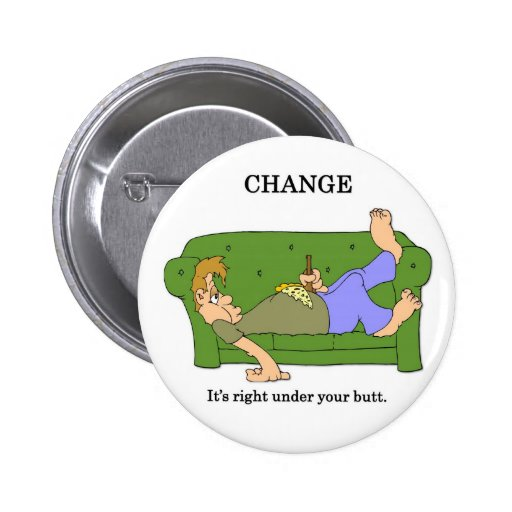If the characters were planning a creative project to encourage others to find 'change,' what might the project entail? The characters decide to launch a campaign called 'Find Your Change,' aimed at inspiring others to seek small yet impactful ways to create positive transformations in their lives. The project includes interactive workshops on goal-setting, a series of motivational videos showcasing personal success stories, and community events that foster collaboration and support. Additionally, they create an app that helps users track their small achievements and connect with others on similar journeys. By emphasizing that change can start from anywhere and at any moment, the project encourages a collective movement towards personal and communal growth. 